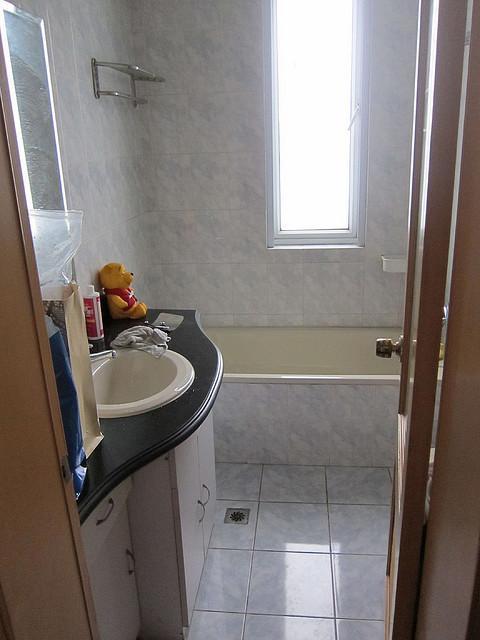How many sinks can be seen?
Give a very brief answer. 1. How many dogs are there?
Give a very brief answer. 0. 